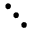Convert formula to latex. <formula><loc_0><loc_0><loc_500><loc_500>\ddots</formula> 